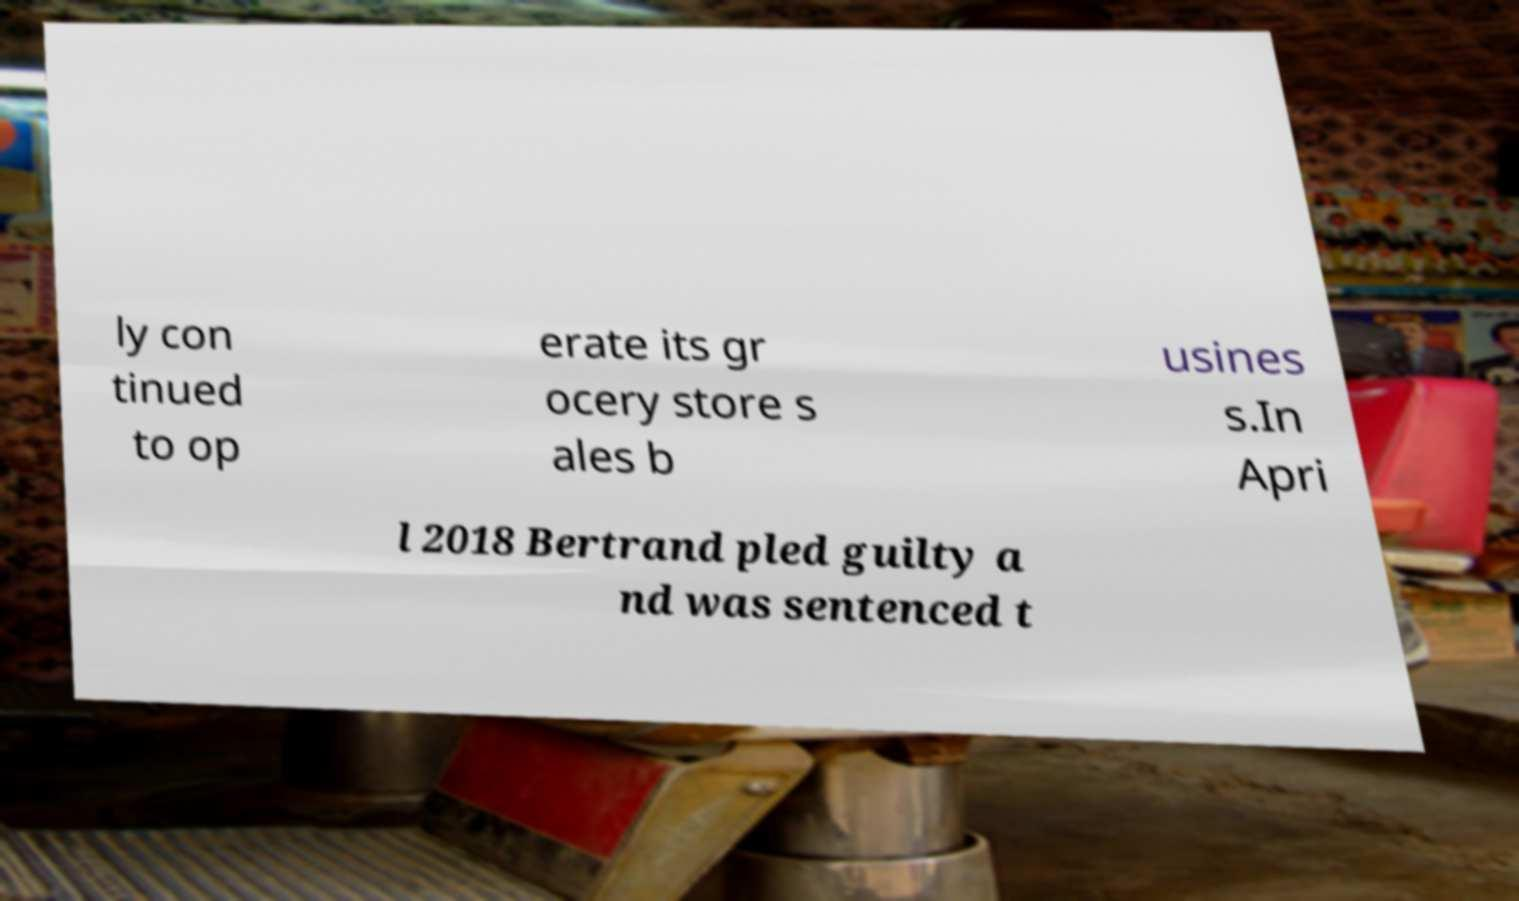I need the written content from this picture converted into text. Can you do that? ly con tinued to op erate its gr ocery store s ales b usines s.In Apri l 2018 Bertrand pled guilty a nd was sentenced t 